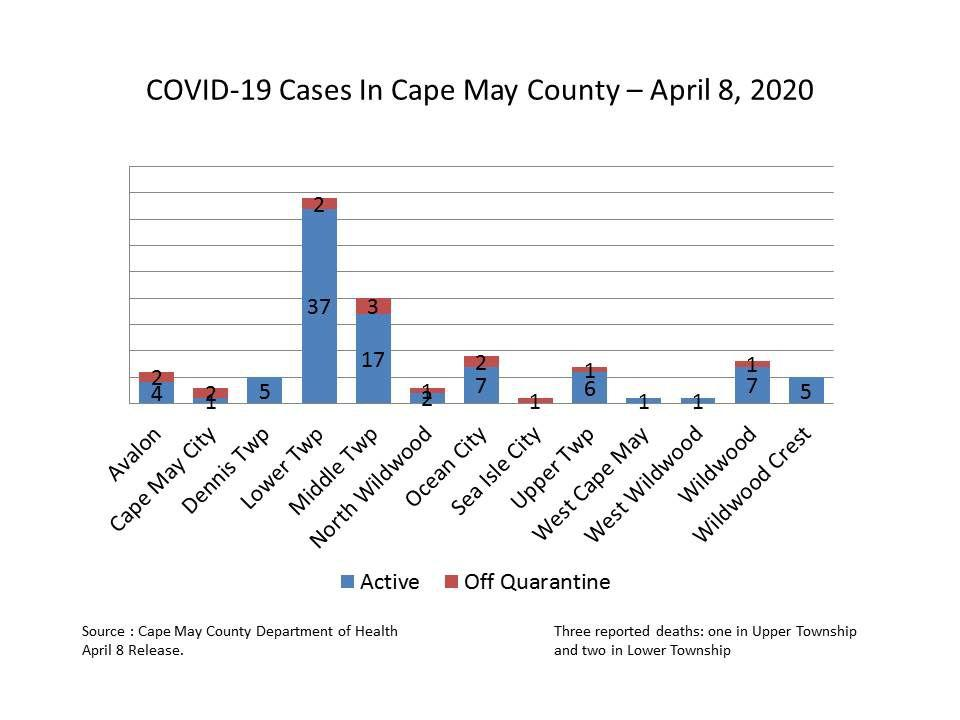Specify some key components in this picture. As of April 8, 2020, there were 37 active COVID-19 cases reported in the Lower Township. As of April 8, 2020, the total number of confirmed COVID-19 cases in Wildwood that had been released from quarantine was 1. As of April 8, 2020, there were 1 active COVID-19 case reported in Cape May City. As of April 8, 2020, there were 3 confirmed cases of Covid-19 in the Middle Township that had been off quarantine. As of April 8, 2020, there were 7 active COVID-19 cases reported in Ocean City. 